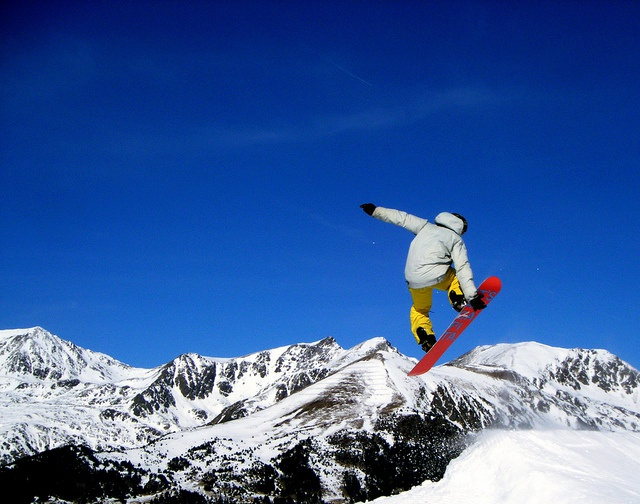Describe the objects in this image and their specific colors. I can see people in black, lightgray, darkgray, and olive tones and snowboard in black, brown, blue, and red tones in this image. 